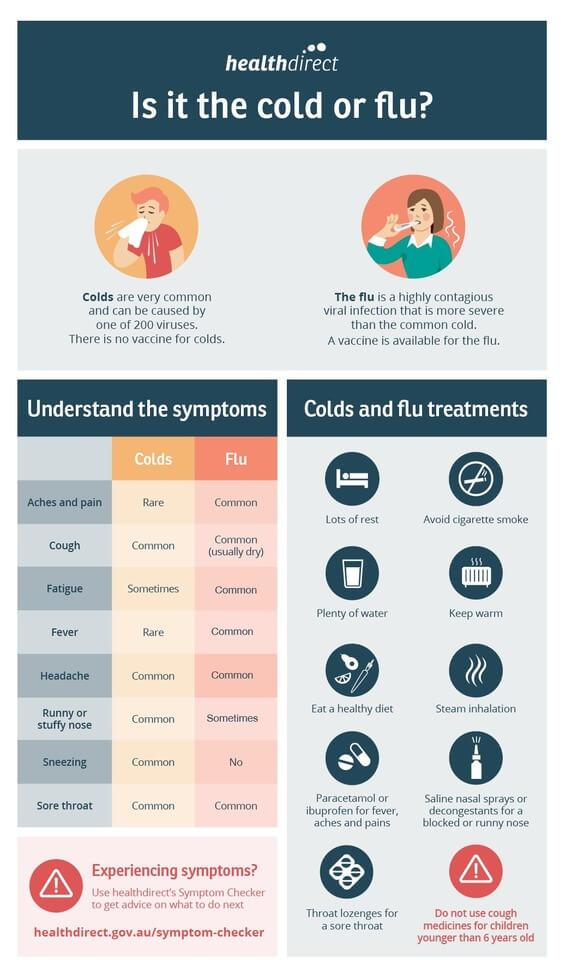Indicate a few pertinent items in this graphic. Both the common cold and the flu can cause symptoms such as a cough, headache, and sore throat. Fatigue is a symptom that can occur sometimes in the cold. Cold symptoms that are relatively rare include aches and pains, as well as a fever. Sneezing is never a symptom of the flu. The flu can cause symptoms such as a runny or stuffy nose, which may occur at times. 